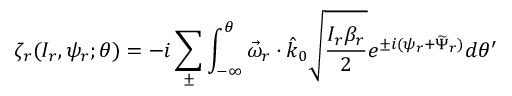<formula> <loc_0><loc_0><loc_500><loc_500>\zeta _ { r } ( I _ { r } , \psi _ { r } ; \theta ) = - i \sum _ { \pm } \int _ { - \infty } ^ { \theta } \vec { \omega } _ { r } \cdot \hat { k } _ { 0 } \sqrt { \frac { I _ { r } \beta _ { r } } { 2 } } e ^ { \pm i ( \psi _ { r } + \widetilde { \Psi } _ { r } ) } d \theta ^ { \prime }</formula> 